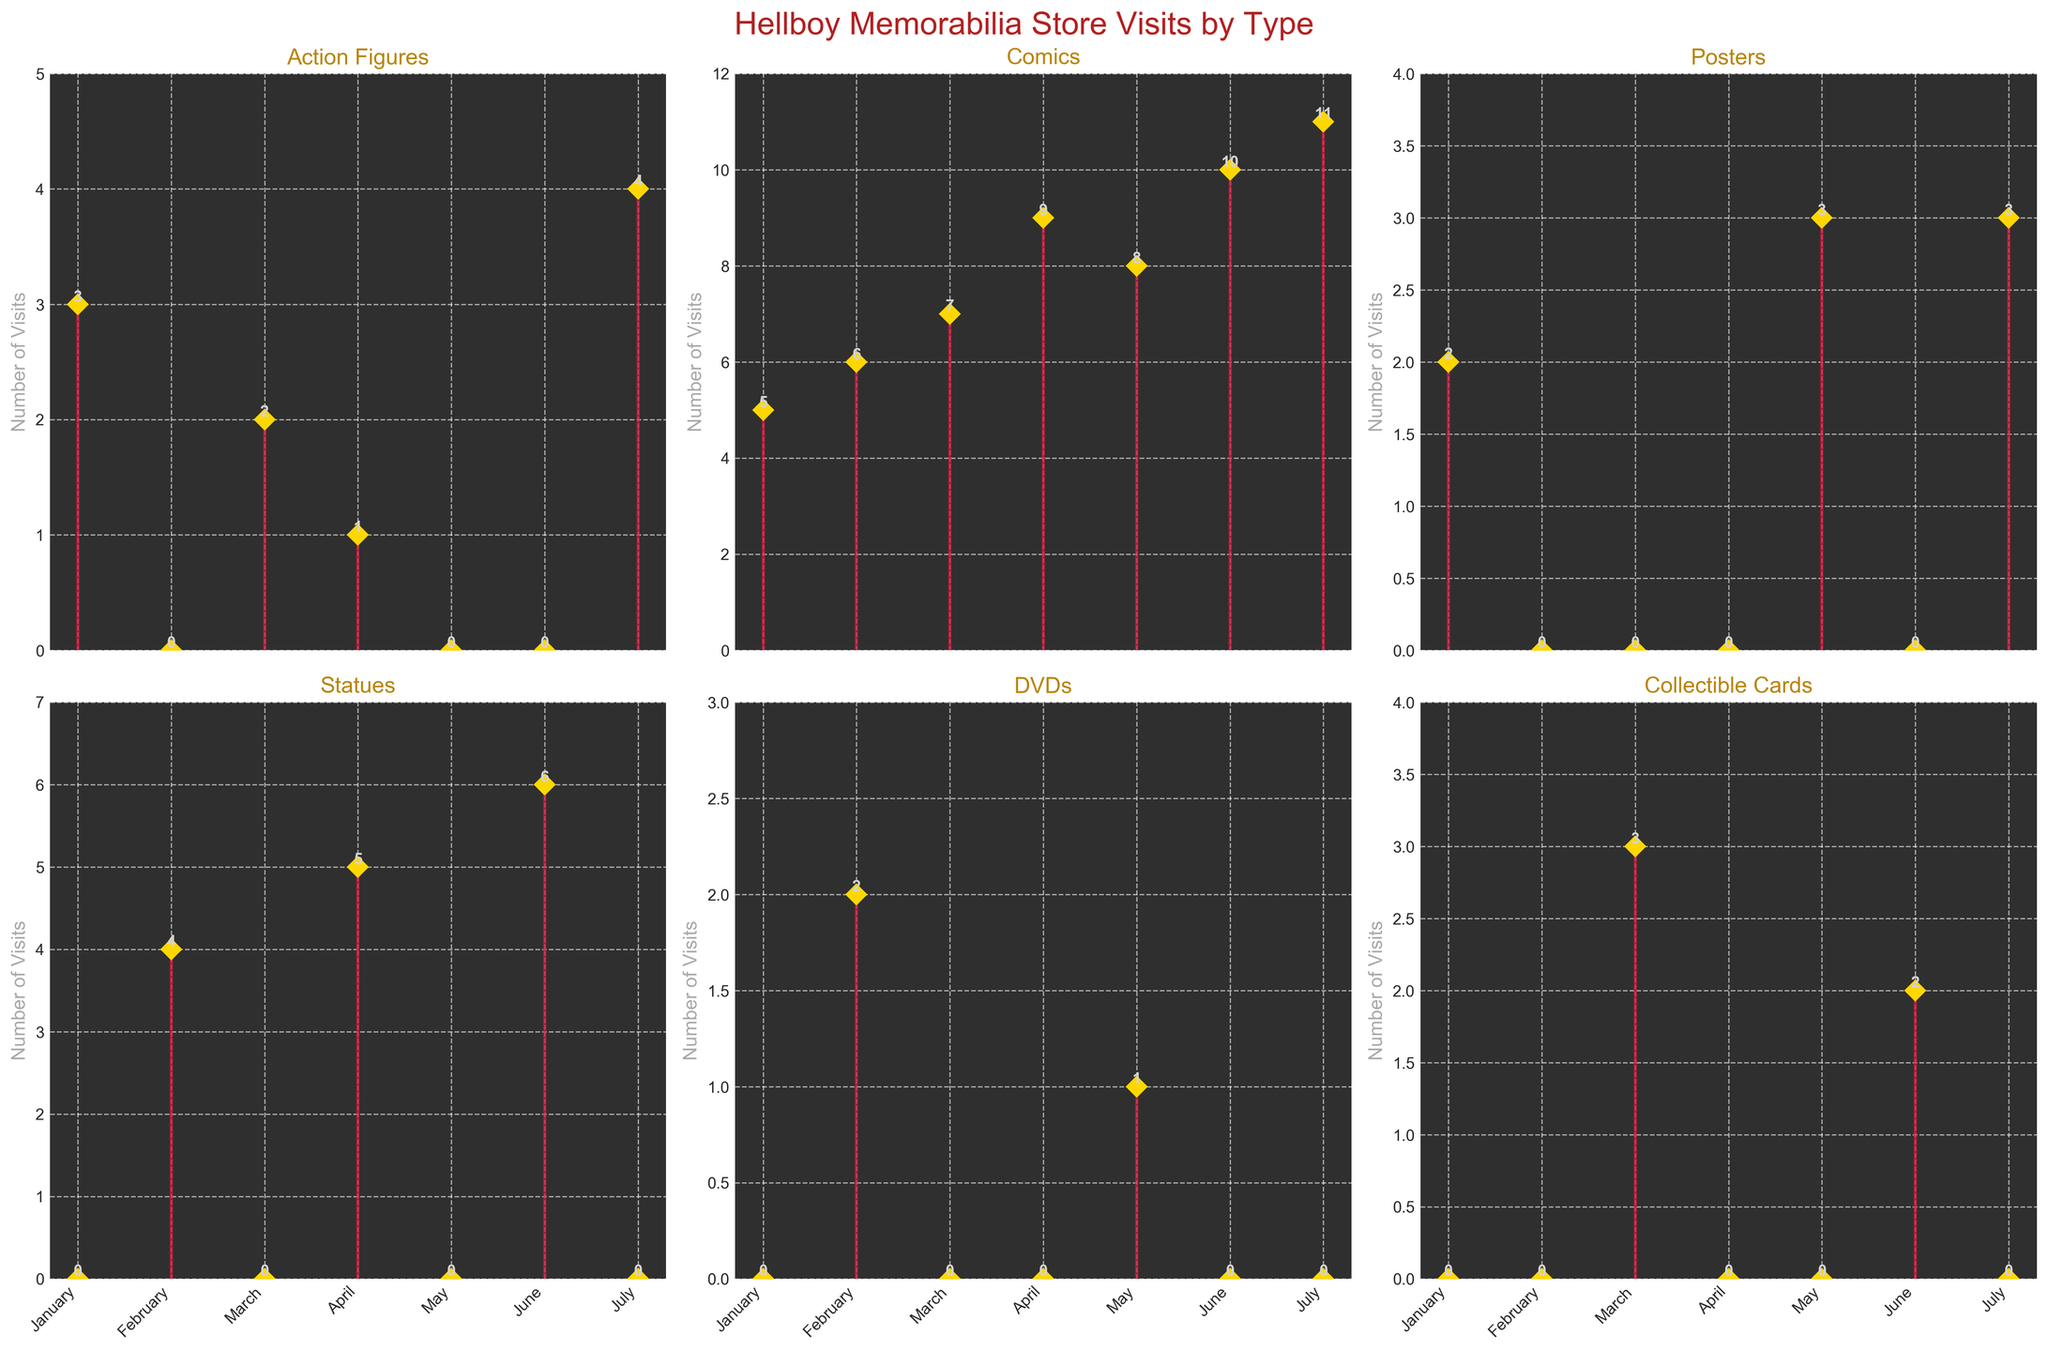What is the title of the figure? The title is usually located at the top of the figure; in this case, it says "Hellboy Memorabilia Store Visits by Type".
Answer: Hellboy Memorabilia Store Visits by Type How many months are displayed in the figure? By counting the x-axis labels on each subplot, you can see that the same set of months is represented. The months shown are January, February, March, April, May, June, and July, totaling to seven months.
Answer: Seven Which memorabilia type had the highest number of visits in a single month? By analyzing the peaks in each subplot, you can see July for Comics reached 11 visits, which is the highest compared to other memorabilia types and months.
Answer: Comics What was the total number of visits for Action Figures across all months? Summing up the number of visits in the Action Figures subplot: 3 (Jan) + 2 (Mar) + 1 (Apr) + 4 (Jul) = 10.
Answer: 10 Which month had the most variety of different memorabilia types purchased? Check the distribution of purchases across different memorabilia types for each month. Both February and April have purchases in four categories.
Answer: February and April How many visits were made to buy Hellboy statues in April? In the subplot for Statues, observe the data point corresponding to April, which shows 5 visits.
Answer: 5 On average, how many visits were made per month for purchasing Comics? Sum the visits across all months for Comics (5+6+7+9+8+10+11 = 56) and divide by the number of months (7): 56/7 = 8.
Answer: 8 During which month was Hellboy: The Right Hand of Doom comic purchased, and how many visits were made? Looking at the Comics subplot, find the month corresponding to Hellboy: The Right Hand of Doom, which is January, with 5 visits.
Answer: January, 5 Which memorabilia type had the lowest total number of visits across all months? Summing the visits for each subplot, the Posters gauge shows the least: 2 (Jan) + 3 (May) + 3 (Jul) = 8.
Answer: Posters Did any memorabilia type have exactly 3 visits in any month? In the subplots, Action Figures in January, Posters in January and July, and Collectible Cards in March met this criterion.
Answer: Yes, Action Figures in January, Posters in January and July, Collectible Cards in March 